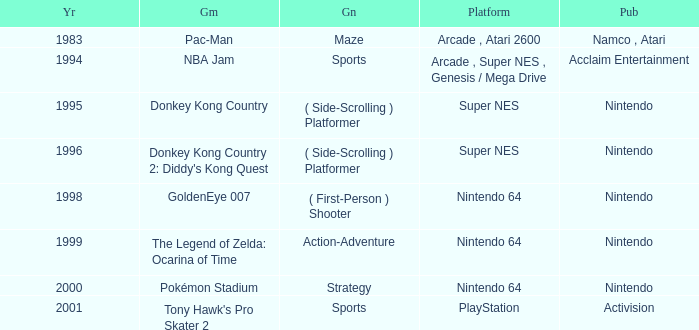Which Genre has a Game of tony hawk's pro skater 2? Sports. 